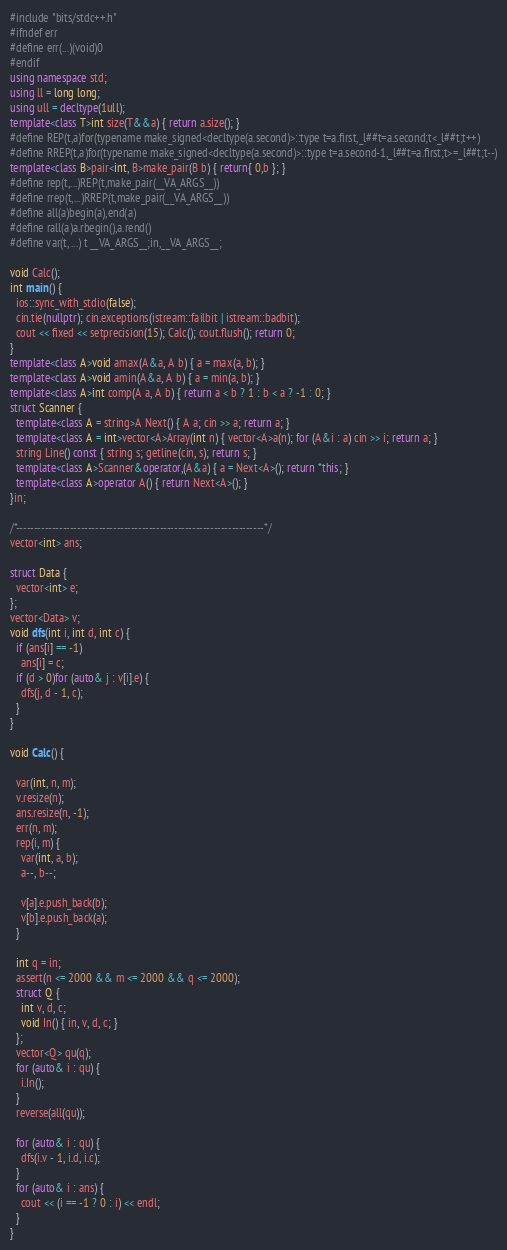Convert code to text. <code><loc_0><loc_0><loc_500><loc_500><_C++_>#include "bits/stdc++.h"
#ifndef err
#define err(...)(void)0
#endif
using namespace std;
using ll = long long;
using ull = decltype(1ull);
template<class T>int size(T&&a) { return a.size(); }
#define REP(t,a)for(typename make_signed<decltype(a.second)>::type t=a.first,_l##t=a.second;t<_l##t;t++)
#define RREP(t,a)for(typename make_signed<decltype(a.second)>::type t=a.second-1,_l##t=a.first;t>=_l##t;t--)
template<class B>pair<int, B>make_pair(B b) { return{ 0,b }; }
#define rep(t,...)REP(t,make_pair(__VA_ARGS__))
#define rrep(t,...)RREP(t,make_pair(__VA_ARGS__))
#define all(a)begin(a),end(a)
#define rall(a)a.rbegin(),a.rend()
#define var(t, ...) t __VA_ARGS__;in,__VA_ARGS__;

void Calc();
int main() {
  ios::sync_with_stdio(false);
  cin.tie(nullptr); cin.exceptions(istream::failbit | istream::badbit);
  cout << fixed << setprecision(15); Calc(); cout.flush(); return 0;
}
template<class A>void amax(A&a, A b) { a = max(a, b); }
template<class A>void amin(A&a, A b) { a = min(a, b); }
template<class A>int comp(A a, A b) { return a < b ? 1 : b < a ? -1 : 0; }
struct Scanner {
  template<class A = string>A Next() { A a; cin >> a; return a; }
  template<class A = int>vector<A>Array(int n) { vector<A>a(n); for (A&i : a) cin >> i; return a; }
  string Line() const { string s; getline(cin, s); return s; }
  template<class A>Scanner&operator,(A&a) { a = Next<A>(); return *this; }
  template<class A>operator A() { return Next<A>(); }
}in;

/*---------------------------------------------------------------------*/
vector<int> ans;

struct Data {
  vector<int> e;
};
vector<Data> v;
void dfs(int i, int d, int c) {
  if (ans[i] == -1)
    ans[i] = c;
  if (d > 0)for (auto& j : v[i].e) {
    dfs(j, d - 1, c);
  }
}

void Calc() {

  var(int, n, m);
  v.resize(n);
  ans.resize(n, -1);
  err(n, m);
  rep(i, m) {
    var(int, a, b);
    a--, b--;

    v[a].e.push_back(b);
    v[b].e.push_back(a);
  }

  int q = in;
  assert(n <= 2000 && m <= 2000 && q <= 2000);
  struct Q {
    int v, d, c;
    void In() { in, v, d, c; }
  };
  vector<Q> qu(q);
  for (auto& i : qu) {
    i.In();
  }
  reverse(all(qu));

  for (auto& i : qu) {
    dfs(i.v - 1, i.d, i.c);
  }
  for (auto& i : ans) {
    cout << (i == -1 ? 0 : i) << endl;
  }
}
</code> 